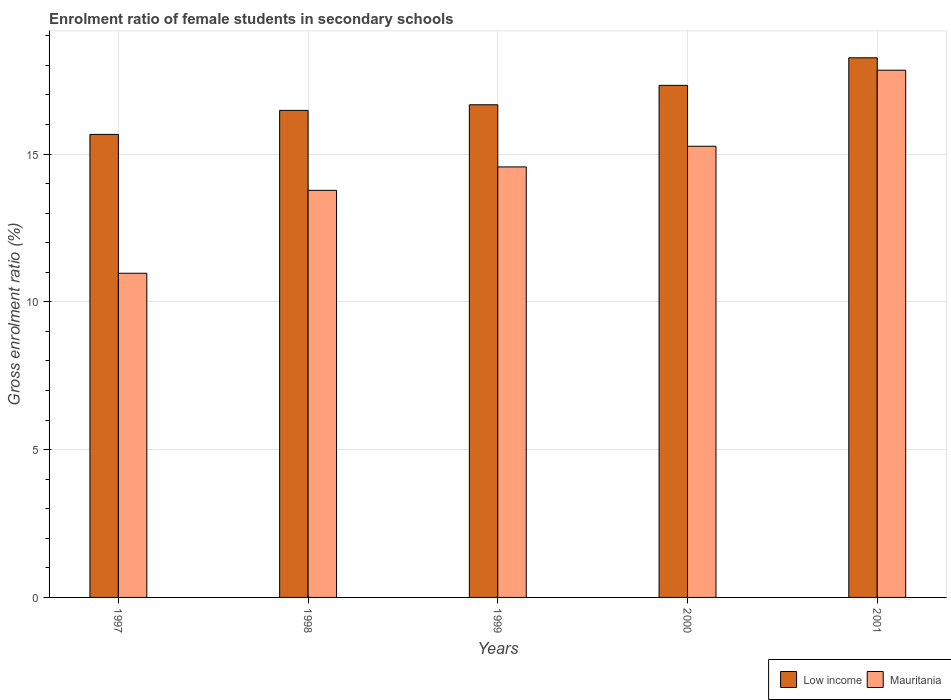Are the number of bars per tick equal to the number of legend labels?
Offer a terse response. Yes. Are the number of bars on each tick of the X-axis equal?
Give a very brief answer. Yes. How many bars are there on the 2nd tick from the left?
Provide a short and direct response. 2. How many bars are there on the 5th tick from the right?
Make the answer very short. 2. What is the enrolment ratio of female students in secondary schools in Mauritania in 1998?
Your answer should be compact. 13.77. Across all years, what is the maximum enrolment ratio of female students in secondary schools in Mauritania?
Keep it short and to the point. 17.84. Across all years, what is the minimum enrolment ratio of female students in secondary schools in Mauritania?
Ensure brevity in your answer.  10.97. In which year was the enrolment ratio of female students in secondary schools in Mauritania maximum?
Make the answer very short. 2001. What is the total enrolment ratio of female students in secondary schools in Mauritania in the graph?
Make the answer very short. 72.4. What is the difference between the enrolment ratio of female students in secondary schools in Mauritania in 1997 and that in 2001?
Ensure brevity in your answer.  -6.87. What is the difference between the enrolment ratio of female students in secondary schools in Low income in 1997 and the enrolment ratio of female students in secondary schools in Mauritania in 2001?
Give a very brief answer. -2.17. What is the average enrolment ratio of female students in secondary schools in Low income per year?
Your answer should be compact. 16.88. In the year 1997, what is the difference between the enrolment ratio of female students in secondary schools in Low income and enrolment ratio of female students in secondary schools in Mauritania?
Provide a succinct answer. 4.7. In how many years, is the enrolment ratio of female students in secondary schools in Mauritania greater than 1 %?
Offer a very short reply. 5. What is the ratio of the enrolment ratio of female students in secondary schools in Mauritania in 1998 to that in 2001?
Your answer should be very brief. 0.77. Is the enrolment ratio of female students in secondary schools in Low income in 2000 less than that in 2001?
Provide a short and direct response. Yes. Is the difference between the enrolment ratio of female students in secondary schools in Low income in 1997 and 1999 greater than the difference between the enrolment ratio of female students in secondary schools in Mauritania in 1997 and 1999?
Offer a terse response. Yes. What is the difference between the highest and the second highest enrolment ratio of female students in secondary schools in Low income?
Ensure brevity in your answer.  0.93. What is the difference between the highest and the lowest enrolment ratio of female students in secondary schools in Mauritania?
Your answer should be very brief. 6.87. In how many years, is the enrolment ratio of female students in secondary schools in Low income greater than the average enrolment ratio of female students in secondary schools in Low income taken over all years?
Offer a very short reply. 2. Is the sum of the enrolment ratio of female students in secondary schools in Mauritania in 1998 and 1999 greater than the maximum enrolment ratio of female students in secondary schools in Low income across all years?
Your response must be concise. Yes. What does the 1st bar from the right in 1997 represents?
Offer a very short reply. Mauritania. How many bars are there?
Provide a succinct answer. 10. Are the values on the major ticks of Y-axis written in scientific E-notation?
Provide a short and direct response. No. Where does the legend appear in the graph?
Provide a succinct answer. Bottom right. How many legend labels are there?
Your response must be concise. 2. How are the legend labels stacked?
Your answer should be very brief. Horizontal. What is the title of the graph?
Provide a short and direct response. Enrolment ratio of female students in secondary schools. What is the label or title of the X-axis?
Offer a very short reply. Years. What is the label or title of the Y-axis?
Make the answer very short. Gross enrolment ratio (%). What is the Gross enrolment ratio (%) of Low income in 1997?
Give a very brief answer. 15.66. What is the Gross enrolment ratio (%) of Mauritania in 1997?
Offer a terse response. 10.97. What is the Gross enrolment ratio (%) of Low income in 1998?
Ensure brevity in your answer.  16.48. What is the Gross enrolment ratio (%) in Mauritania in 1998?
Keep it short and to the point. 13.77. What is the Gross enrolment ratio (%) of Low income in 1999?
Provide a short and direct response. 16.67. What is the Gross enrolment ratio (%) in Mauritania in 1999?
Offer a terse response. 14.56. What is the Gross enrolment ratio (%) in Low income in 2000?
Provide a short and direct response. 17.32. What is the Gross enrolment ratio (%) in Mauritania in 2000?
Ensure brevity in your answer.  15.26. What is the Gross enrolment ratio (%) of Low income in 2001?
Make the answer very short. 18.26. What is the Gross enrolment ratio (%) in Mauritania in 2001?
Provide a short and direct response. 17.84. Across all years, what is the maximum Gross enrolment ratio (%) of Low income?
Offer a terse response. 18.26. Across all years, what is the maximum Gross enrolment ratio (%) in Mauritania?
Your answer should be compact. 17.84. Across all years, what is the minimum Gross enrolment ratio (%) in Low income?
Ensure brevity in your answer.  15.66. Across all years, what is the minimum Gross enrolment ratio (%) in Mauritania?
Your answer should be compact. 10.97. What is the total Gross enrolment ratio (%) in Low income in the graph?
Give a very brief answer. 84.39. What is the total Gross enrolment ratio (%) in Mauritania in the graph?
Your answer should be very brief. 72.4. What is the difference between the Gross enrolment ratio (%) in Low income in 1997 and that in 1998?
Ensure brevity in your answer.  -0.81. What is the difference between the Gross enrolment ratio (%) in Mauritania in 1997 and that in 1998?
Your response must be concise. -2.81. What is the difference between the Gross enrolment ratio (%) of Low income in 1997 and that in 1999?
Offer a terse response. -1. What is the difference between the Gross enrolment ratio (%) of Mauritania in 1997 and that in 1999?
Provide a short and direct response. -3.6. What is the difference between the Gross enrolment ratio (%) in Low income in 1997 and that in 2000?
Your response must be concise. -1.66. What is the difference between the Gross enrolment ratio (%) in Mauritania in 1997 and that in 2000?
Provide a succinct answer. -4.3. What is the difference between the Gross enrolment ratio (%) in Low income in 1997 and that in 2001?
Keep it short and to the point. -2.59. What is the difference between the Gross enrolment ratio (%) of Mauritania in 1997 and that in 2001?
Offer a terse response. -6.87. What is the difference between the Gross enrolment ratio (%) in Low income in 1998 and that in 1999?
Your answer should be compact. -0.19. What is the difference between the Gross enrolment ratio (%) of Mauritania in 1998 and that in 1999?
Offer a very short reply. -0.79. What is the difference between the Gross enrolment ratio (%) in Low income in 1998 and that in 2000?
Give a very brief answer. -0.85. What is the difference between the Gross enrolment ratio (%) in Mauritania in 1998 and that in 2000?
Provide a short and direct response. -1.49. What is the difference between the Gross enrolment ratio (%) in Low income in 1998 and that in 2001?
Your answer should be compact. -1.78. What is the difference between the Gross enrolment ratio (%) of Mauritania in 1998 and that in 2001?
Your answer should be very brief. -4.06. What is the difference between the Gross enrolment ratio (%) in Low income in 1999 and that in 2000?
Keep it short and to the point. -0.66. What is the difference between the Gross enrolment ratio (%) of Mauritania in 1999 and that in 2000?
Make the answer very short. -0.7. What is the difference between the Gross enrolment ratio (%) in Low income in 1999 and that in 2001?
Give a very brief answer. -1.59. What is the difference between the Gross enrolment ratio (%) in Mauritania in 1999 and that in 2001?
Offer a terse response. -3.27. What is the difference between the Gross enrolment ratio (%) in Low income in 2000 and that in 2001?
Offer a very short reply. -0.93. What is the difference between the Gross enrolment ratio (%) of Mauritania in 2000 and that in 2001?
Provide a succinct answer. -2.57. What is the difference between the Gross enrolment ratio (%) in Low income in 1997 and the Gross enrolment ratio (%) in Mauritania in 1998?
Offer a terse response. 1.89. What is the difference between the Gross enrolment ratio (%) in Low income in 1997 and the Gross enrolment ratio (%) in Mauritania in 1999?
Give a very brief answer. 1.1. What is the difference between the Gross enrolment ratio (%) in Low income in 1997 and the Gross enrolment ratio (%) in Mauritania in 2000?
Make the answer very short. 0.4. What is the difference between the Gross enrolment ratio (%) of Low income in 1997 and the Gross enrolment ratio (%) of Mauritania in 2001?
Your response must be concise. -2.17. What is the difference between the Gross enrolment ratio (%) in Low income in 1998 and the Gross enrolment ratio (%) in Mauritania in 1999?
Keep it short and to the point. 1.91. What is the difference between the Gross enrolment ratio (%) in Low income in 1998 and the Gross enrolment ratio (%) in Mauritania in 2000?
Make the answer very short. 1.21. What is the difference between the Gross enrolment ratio (%) in Low income in 1998 and the Gross enrolment ratio (%) in Mauritania in 2001?
Provide a succinct answer. -1.36. What is the difference between the Gross enrolment ratio (%) in Low income in 1999 and the Gross enrolment ratio (%) in Mauritania in 2000?
Your answer should be compact. 1.4. What is the difference between the Gross enrolment ratio (%) of Low income in 1999 and the Gross enrolment ratio (%) of Mauritania in 2001?
Provide a short and direct response. -1.17. What is the difference between the Gross enrolment ratio (%) in Low income in 2000 and the Gross enrolment ratio (%) in Mauritania in 2001?
Provide a short and direct response. -0.51. What is the average Gross enrolment ratio (%) in Low income per year?
Offer a very short reply. 16.88. What is the average Gross enrolment ratio (%) in Mauritania per year?
Make the answer very short. 14.48. In the year 1997, what is the difference between the Gross enrolment ratio (%) in Low income and Gross enrolment ratio (%) in Mauritania?
Keep it short and to the point. 4.7. In the year 1998, what is the difference between the Gross enrolment ratio (%) of Low income and Gross enrolment ratio (%) of Mauritania?
Your answer should be very brief. 2.71. In the year 1999, what is the difference between the Gross enrolment ratio (%) in Low income and Gross enrolment ratio (%) in Mauritania?
Your response must be concise. 2.1. In the year 2000, what is the difference between the Gross enrolment ratio (%) of Low income and Gross enrolment ratio (%) of Mauritania?
Ensure brevity in your answer.  2.06. In the year 2001, what is the difference between the Gross enrolment ratio (%) in Low income and Gross enrolment ratio (%) in Mauritania?
Your answer should be very brief. 0.42. What is the ratio of the Gross enrolment ratio (%) of Low income in 1997 to that in 1998?
Give a very brief answer. 0.95. What is the ratio of the Gross enrolment ratio (%) in Mauritania in 1997 to that in 1998?
Your response must be concise. 0.8. What is the ratio of the Gross enrolment ratio (%) of Low income in 1997 to that in 1999?
Offer a terse response. 0.94. What is the ratio of the Gross enrolment ratio (%) in Mauritania in 1997 to that in 1999?
Offer a terse response. 0.75. What is the ratio of the Gross enrolment ratio (%) in Low income in 1997 to that in 2000?
Ensure brevity in your answer.  0.9. What is the ratio of the Gross enrolment ratio (%) in Mauritania in 1997 to that in 2000?
Offer a terse response. 0.72. What is the ratio of the Gross enrolment ratio (%) in Low income in 1997 to that in 2001?
Make the answer very short. 0.86. What is the ratio of the Gross enrolment ratio (%) in Mauritania in 1997 to that in 2001?
Offer a very short reply. 0.61. What is the ratio of the Gross enrolment ratio (%) of Low income in 1998 to that in 1999?
Your answer should be very brief. 0.99. What is the ratio of the Gross enrolment ratio (%) in Mauritania in 1998 to that in 1999?
Your answer should be very brief. 0.95. What is the ratio of the Gross enrolment ratio (%) in Low income in 1998 to that in 2000?
Your answer should be very brief. 0.95. What is the ratio of the Gross enrolment ratio (%) in Mauritania in 1998 to that in 2000?
Your answer should be very brief. 0.9. What is the ratio of the Gross enrolment ratio (%) of Low income in 1998 to that in 2001?
Your answer should be very brief. 0.9. What is the ratio of the Gross enrolment ratio (%) in Mauritania in 1998 to that in 2001?
Keep it short and to the point. 0.77. What is the ratio of the Gross enrolment ratio (%) of Low income in 1999 to that in 2000?
Your answer should be very brief. 0.96. What is the ratio of the Gross enrolment ratio (%) of Mauritania in 1999 to that in 2000?
Your answer should be very brief. 0.95. What is the ratio of the Gross enrolment ratio (%) in Low income in 1999 to that in 2001?
Make the answer very short. 0.91. What is the ratio of the Gross enrolment ratio (%) in Mauritania in 1999 to that in 2001?
Your response must be concise. 0.82. What is the ratio of the Gross enrolment ratio (%) in Low income in 2000 to that in 2001?
Your answer should be compact. 0.95. What is the ratio of the Gross enrolment ratio (%) in Mauritania in 2000 to that in 2001?
Provide a succinct answer. 0.86. What is the difference between the highest and the second highest Gross enrolment ratio (%) in Low income?
Keep it short and to the point. 0.93. What is the difference between the highest and the second highest Gross enrolment ratio (%) in Mauritania?
Offer a terse response. 2.57. What is the difference between the highest and the lowest Gross enrolment ratio (%) in Low income?
Ensure brevity in your answer.  2.59. What is the difference between the highest and the lowest Gross enrolment ratio (%) of Mauritania?
Provide a succinct answer. 6.87. 